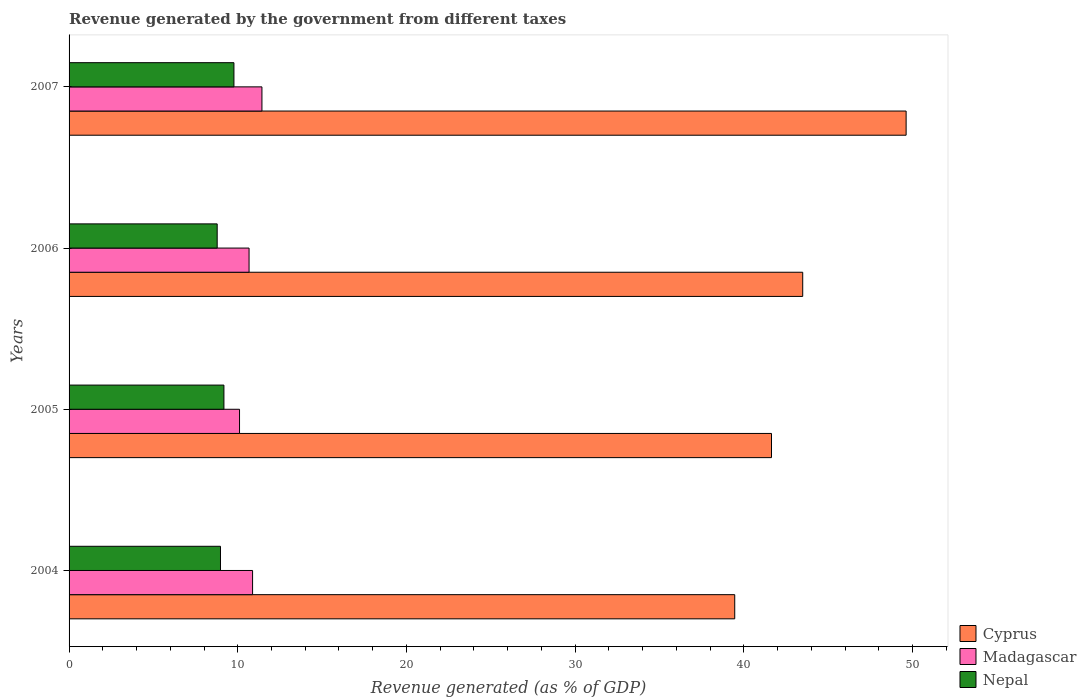Are the number of bars per tick equal to the number of legend labels?
Give a very brief answer. Yes. Are the number of bars on each tick of the Y-axis equal?
Offer a terse response. Yes. How many bars are there on the 1st tick from the bottom?
Provide a succinct answer. 3. In how many cases, is the number of bars for a given year not equal to the number of legend labels?
Provide a succinct answer. 0. What is the revenue generated by the government in Madagascar in 2005?
Provide a succinct answer. 10.1. Across all years, what is the maximum revenue generated by the government in Nepal?
Your answer should be very brief. 9.77. Across all years, what is the minimum revenue generated by the government in Cyprus?
Your answer should be very brief. 39.46. In which year was the revenue generated by the government in Nepal maximum?
Provide a succinct answer. 2007. In which year was the revenue generated by the government in Madagascar minimum?
Make the answer very short. 2005. What is the total revenue generated by the government in Madagascar in the graph?
Provide a short and direct response. 43.08. What is the difference between the revenue generated by the government in Nepal in 2004 and that in 2005?
Your answer should be compact. -0.2. What is the difference between the revenue generated by the government in Cyprus in 2006 and the revenue generated by the government in Nepal in 2007?
Offer a very short reply. 33.72. What is the average revenue generated by the government in Nepal per year?
Give a very brief answer. 9.18. In the year 2007, what is the difference between the revenue generated by the government in Madagascar and revenue generated by the government in Nepal?
Your response must be concise. 1.66. In how many years, is the revenue generated by the government in Cyprus greater than 42 %?
Give a very brief answer. 2. What is the ratio of the revenue generated by the government in Cyprus in 2006 to that in 2007?
Your answer should be very brief. 0.88. Is the revenue generated by the government in Nepal in 2005 less than that in 2006?
Your answer should be very brief. No. What is the difference between the highest and the second highest revenue generated by the government in Madagascar?
Keep it short and to the point. 0.56. What is the difference between the highest and the lowest revenue generated by the government in Cyprus?
Your answer should be compact. 10.16. What does the 3rd bar from the top in 2005 represents?
Ensure brevity in your answer.  Cyprus. What does the 1st bar from the bottom in 2005 represents?
Your answer should be very brief. Cyprus. How many bars are there?
Offer a terse response. 12. What is the difference between two consecutive major ticks on the X-axis?
Your answer should be very brief. 10. Are the values on the major ticks of X-axis written in scientific E-notation?
Ensure brevity in your answer.  No. Does the graph contain any zero values?
Your answer should be very brief. No. Does the graph contain grids?
Give a very brief answer. No. Where does the legend appear in the graph?
Offer a very short reply. Bottom right. How many legend labels are there?
Provide a succinct answer. 3. How are the legend labels stacked?
Your answer should be compact. Vertical. What is the title of the graph?
Keep it short and to the point. Revenue generated by the government from different taxes. Does "Montenegro" appear as one of the legend labels in the graph?
Your response must be concise. No. What is the label or title of the X-axis?
Keep it short and to the point. Revenue generated (as % of GDP). What is the Revenue generated (as % of GDP) in Cyprus in 2004?
Offer a very short reply. 39.46. What is the Revenue generated (as % of GDP) of Madagascar in 2004?
Give a very brief answer. 10.88. What is the Revenue generated (as % of GDP) in Nepal in 2004?
Provide a succinct answer. 8.97. What is the Revenue generated (as % of GDP) of Cyprus in 2005?
Make the answer very short. 41.64. What is the Revenue generated (as % of GDP) of Madagascar in 2005?
Provide a succinct answer. 10.1. What is the Revenue generated (as % of GDP) of Nepal in 2005?
Your answer should be very brief. 9.18. What is the Revenue generated (as % of GDP) of Cyprus in 2006?
Provide a short and direct response. 43.49. What is the Revenue generated (as % of GDP) of Madagascar in 2006?
Provide a succinct answer. 10.67. What is the Revenue generated (as % of GDP) in Nepal in 2006?
Give a very brief answer. 8.78. What is the Revenue generated (as % of GDP) of Cyprus in 2007?
Your answer should be very brief. 49.62. What is the Revenue generated (as % of GDP) of Madagascar in 2007?
Your answer should be very brief. 11.43. What is the Revenue generated (as % of GDP) in Nepal in 2007?
Provide a short and direct response. 9.77. Across all years, what is the maximum Revenue generated (as % of GDP) in Cyprus?
Keep it short and to the point. 49.62. Across all years, what is the maximum Revenue generated (as % of GDP) of Madagascar?
Make the answer very short. 11.43. Across all years, what is the maximum Revenue generated (as % of GDP) in Nepal?
Make the answer very short. 9.77. Across all years, what is the minimum Revenue generated (as % of GDP) in Cyprus?
Offer a very short reply. 39.46. Across all years, what is the minimum Revenue generated (as % of GDP) in Madagascar?
Make the answer very short. 10.1. Across all years, what is the minimum Revenue generated (as % of GDP) of Nepal?
Your answer should be compact. 8.78. What is the total Revenue generated (as % of GDP) in Cyprus in the graph?
Your response must be concise. 174.2. What is the total Revenue generated (as % of GDP) of Madagascar in the graph?
Your response must be concise. 43.08. What is the total Revenue generated (as % of GDP) of Nepal in the graph?
Offer a terse response. 36.71. What is the difference between the Revenue generated (as % of GDP) of Cyprus in 2004 and that in 2005?
Keep it short and to the point. -2.18. What is the difference between the Revenue generated (as % of GDP) of Madagascar in 2004 and that in 2005?
Offer a terse response. 0.77. What is the difference between the Revenue generated (as % of GDP) in Nepal in 2004 and that in 2005?
Provide a succinct answer. -0.2. What is the difference between the Revenue generated (as % of GDP) in Cyprus in 2004 and that in 2006?
Your response must be concise. -4.03. What is the difference between the Revenue generated (as % of GDP) of Madagascar in 2004 and that in 2006?
Your answer should be very brief. 0.21. What is the difference between the Revenue generated (as % of GDP) in Nepal in 2004 and that in 2006?
Provide a succinct answer. 0.2. What is the difference between the Revenue generated (as % of GDP) in Cyprus in 2004 and that in 2007?
Give a very brief answer. -10.16. What is the difference between the Revenue generated (as % of GDP) of Madagascar in 2004 and that in 2007?
Your response must be concise. -0.56. What is the difference between the Revenue generated (as % of GDP) of Nepal in 2004 and that in 2007?
Ensure brevity in your answer.  -0.8. What is the difference between the Revenue generated (as % of GDP) of Cyprus in 2005 and that in 2006?
Provide a short and direct response. -1.85. What is the difference between the Revenue generated (as % of GDP) of Madagascar in 2005 and that in 2006?
Your response must be concise. -0.57. What is the difference between the Revenue generated (as % of GDP) of Nepal in 2005 and that in 2006?
Offer a very short reply. 0.4. What is the difference between the Revenue generated (as % of GDP) in Cyprus in 2005 and that in 2007?
Make the answer very short. -7.98. What is the difference between the Revenue generated (as % of GDP) in Madagascar in 2005 and that in 2007?
Keep it short and to the point. -1.33. What is the difference between the Revenue generated (as % of GDP) in Nepal in 2005 and that in 2007?
Your response must be concise. -0.59. What is the difference between the Revenue generated (as % of GDP) in Cyprus in 2006 and that in 2007?
Your response must be concise. -6.13. What is the difference between the Revenue generated (as % of GDP) of Madagascar in 2006 and that in 2007?
Make the answer very short. -0.76. What is the difference between the Revenue generated (as % of GDP) in Nepal in 2006 and that in 2007?
Your answer should be very brief. -0.99. What is the difference between the Revenue generated (as % of GDP) in Cyprus in 2004 and the Revenue generated (as % of GDP) in Madagascar in 2005?
Keep it short and to the point. 29.35. What is the difference between the Revenue generated (as % of GDP) of Cyprus in 2004 and the Revenue generated (as % of GDP) of Nepal in 2005?
Your answer should be very brief. 30.28. What is the difference between the Revenue generated (as % of GDP) of Madagascar in 2004 and the Revenue generated (as % of GDP) of Nepal in 2005?
Your answer should be very brief. 1.7. What is the difference between the Revenue generated (as % of GDP) of Cyprus in 2004 and the Revenue generated (as % of GDP) of Madagascar in 2006?
Offer a very short reply. 28.79. What is the difference between the Revenue generated (as % of GDP) in Cyprus in 2004 and the Revenue generated (as % of GDP) in Nepal in 2006?
Provide a succinct answer. 30.68. What is the difference between the Revenue generated (as % of GDP) of Madagascar in 2004 and the Revenue generated (as % of GDP) of Nepal in 2006?
Give a very brief answer. 2.1. What is the difference between the Revenue generated (as % of GDP) in Cyprus in 2004 and the Revenue generated (as % of GDP) in Madagascar in 2007?
Your answer should be very brief. 28.03. What is the difference between the Revenue generated (as % of GDP) of Cyprus in 2004 and the Revenue generated (as % of GDP) of Nepal in 2007?
Make the answer very short. 29.69. What is the difference between the Revenue generated (as % of GDP) in Madagascar in 2004 and the Revenue generated (as % of GDP) in Nepal in 2007?
Give a very brief answer. 1.11. What is the difference between the Revenue generated (as % of GDP) in Cyprus in 2005 and the Revenue generated (as % of GDP) in Madagascar in 2006?
Provide a short and direct response. 30.97. What is the difference between the Revenue generated (as % of GDP) in Cyprus in 2005 and the Revenue generated (as % of GDP) in Nepal in 2006?
Provide a succinct answer. 32.86. What is the difference between the Revenue generated (as % of GDP) of Madagascar in 2005 and the Revenue generated (as % of GDP) of Nepal in 2006?
Your response must be concise. 1.32. What is the difference between the Revenue generated (as % of GDP) in Cyprus in 2005 and the Revenue generated (as % of GDP) in Madagascar in 2007?
Make the answer very short. 30.2. What is the difference between the Revenue generated (as % of GDP) of Cyprus in 2005 and the Revenue generated (as % of GDP) of Nepal in 2007?
Your answer should be very brief. 31.87. What is the difference between the Revenue generated (as % of GDP) of Madagascar in 2005 and the Revenue generated (as % of GDP) of Nepal in 2007?
Your answer should be very brief. 0.33. What is the difference between the Revenue generated (as % of GDP) in Cyprus in 2006 and the Revenue generated (as % of GDP) in Madagascar in 2007?
Your response must be concise. 32.05. What is the difference between the Revenue generated (as % of GDP) in Cyprus in 2006 and the Revenue generated (as % of GDP) in Nepal in 2007?
Keep it short and to the point. 33.72. What is the difference between the Revenue generated (as % of GDP) in Madagascar in 2006 and the Revenue generated (as % of GDP) in Nepal in 2007?
Offer a very short reply. 0.9. What is the average Revenue generated (as % of GDP) in Cyprus per year?
Give a very brief answer. 43.55. What is the average Revenue generated (as % of GDP) of Madagascar per year?
Offer a terse response. 10.77. What is the average Revenue generated (as % of GDP) in Nepal per year?
Keep it short and to the point. 9.18. In the year 2004, what is the difference between the Revenue generated (as % of GDP) in Cyprus and Revenue generated (as % of GDP) in Madagascar?
Your response must be concise. 28.58. In the year 2004, what is the difference between the Revenue generated (as % of GDP) in Cyprus and Revenue generated (as % of GDP) in Nepal?
Offer a terse response. 30.48. In the year 2004, what is the difference between the Revenue generated (as % of GDP) of Madagascar and Revenue generated (as % of GDP) of Nepal?
Keep it short and to the point. 1.9. In the year 2005, what is the difference between the Revenue generated (as % of GDP) of Cyprus and Revenue generated (as % of GDP) of Madagascar?
Your answer should be compact. 31.53. In the year 2005, what is the difference between the Revenue generated (as % of GDP) of Cyprus and Revenue generated (as % of GDP) of Nepal?
Your response must be concise. 32.46. In the year 2005, what is the difference between the Revenue generated (as % of GDP) in Madagascar and Revenue generated (as % of GDP) in Nepal?
Offer a terse response. 0.92. In the year 2006, what is the difference between the Revenue generated (as % of GDP) in Cyprus and Revenue generated (as % of GDP) in Madagascar?
Provide a short and direct response. 32.82. In the year 2006, what is the difference between the Revenue generated (as % of GDP) in Cyprus and Revenue generated (as % of GDP) in Nepal?
Keep it short and to the point. 34.71. In the year 2006, what is the difference between the Revenue generated (as % of GDP) of Madagascar and Revenue generated (as % of GDP) of Nepal?
Your answer should be compact. 1.89. In the year 2007, what is the difference between the Revenue generated (as % of GDP) of Cyprus and Revenue generated (as % of GDP) of Madagascar?
Offer a terse response. 38.18. In the year 2007, what is the difference between the Revenue generated (as % of GDP) in Cyprus and Revenue generated (as % of GDP) in Nepal?
Your response must be concise. 39.85. In the year 2007, what is the difference between the Revenue generated (as % of GDP) in Madagascar and Revenue generated (as % of GDP) in Nepal?
Provide a succinct answer. 1.66. What is the ratio of the Revenue generated (as % of GDP) of Cyprus in 2004 to that in 2005?
Your answer should be very brief. 0.95. What is the ratio of the Revenue generated (as % of GDP) in Madagascar in 2004 to that in 2005?
Provide a short and direct response. 1.08. What is the ratio of the Revenue generated (as % of GDP) in Nepal in 2004 to that in 2005?
Offer a very short reply. 0.98. What is the ratio of the Revenue generated (as % of GDP) of Cyprus in 2004 to that in 2006?
Your answer should be very brief. 0.91. What is the ratio of the Revenue generated (as % of GDP) in Madagascar in 2004 to that in 2006?
Your answer should be very brief. 1.02. What is the ratio of the Revenue generated (as % of GDP) of Nepal in 2004 to that in 2006?
Give a very brief answer. 1.02. What is the ratio of the Revenue generated (as % of GDP) of Cyprus in 2004 to that in 2007?
Provide a succinct answer. 0.8. What is the ratio of the Revenue generated (as % of GDP) of Madagascar in 2004 to that in 2007?
Provide a succinct answer. 0.95. What is the ratio of the Revenue generated (as % of GDP) in Nepal in 2004 to that in 2007?
Give a very brief answer. 0.92. What is the ratio of the Revenue generated (as % of GDP) in Cyprus in 2005 to that in 2006?
Ensure brevity in your answer.  0.96. What is the ratio of the Revenue generated (as % of GDP) of Madagascar in 2005 to that in 2006?
Your response must be concise. 0.95. What is the ratio of the Revenue generated (as % of GDP) in Nepal in 2005 to that in 2006?
Provide a succinct answer. 1.05. What is the ratio of the Revenue generated (as % of GDP) of Cyprus in 2005 to that in 2007?
Your answer should be compact. 0.84. What is the ratio of the Revenue generated (as % of GDP) of Madagascar in 2005 to that in 2007?
Your response must be concise. 0.88. What is the ratio of the Revenue generated (as % of GDP) of Nepal in 2005 to that in 2007?
Make the answer very short. 0.94. What is the ratio of the Revenue generated (as % of GDP) of Cyprus in 2006 to that in 2007?
Give a very brief answer. 0.88. What is the ratio of the Revenue generated (as % of GDP) in Madagascar in 2006 to that in 2007?
Ensure brevity in your answer.  0.93. What is the ratio of the Revenue generated (as % of GDP) of Nepal in 2006 to that in 2007?
Your response must be concise. 0.9. What is the difference between the highest and the second highest Revenue generated (as % of GDP) of Cyprus?
Provide a short and direct response. 6.13. What is the difference between the highest and the second highest Revenue generated (as % of GDP) in Madagascar?
Your answer should be very brief. 0.56. What is the difference between the highest and the second highest Revenue generated (as % of GDP) of Nepal?
Keep it short and to the point. 0.59. What is the difference between the highest and the lowest Revenue generated (as % of GDP) in Cyprus?
Give a very brief answer. 10.16. What is the difference between the highest and the lowest Revenue generated (as % of GDP) in Madagascar?
Make the answer very short. 1.33. What is the difference between the highest and the lowest Revenue generated (as % of GDP) of Nepal?
Give a very brief answer. 0.99. 